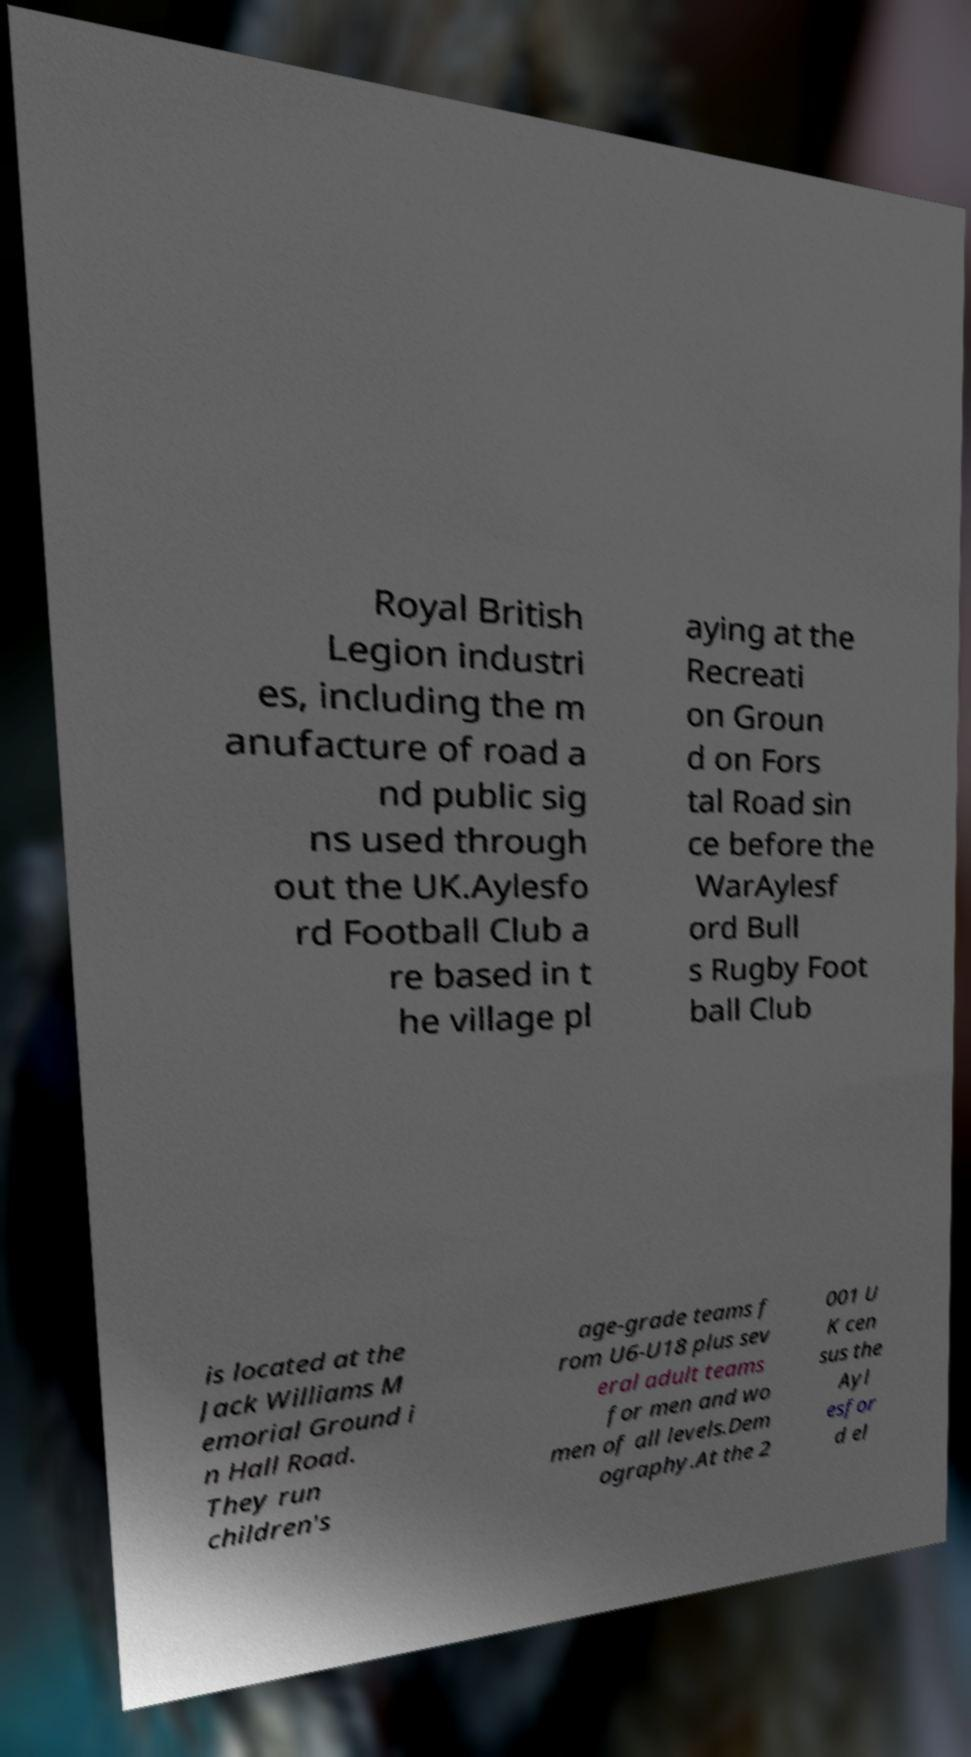Could you assist in decoding the text presented in this image and type it out clearly? Royal British Legion industri es, including the m anufacture of road a nd public sig ns used through out the UK.Aylesfo rd Football Club a re based in t he village pl aying at the Recreati on Groun d on Fors tal Road sin ce before the WarAylesf ord Bull s Rugby Foot ball Club is located at the Jack Williams M emorial Ground i n Hall Road. They run children's age-grade teams f rom U6-U18 plus sev eral adult teams for men and wo men of all levels.Dem ography.At the 2 001 U K cen sus the Ayl esfor d el 